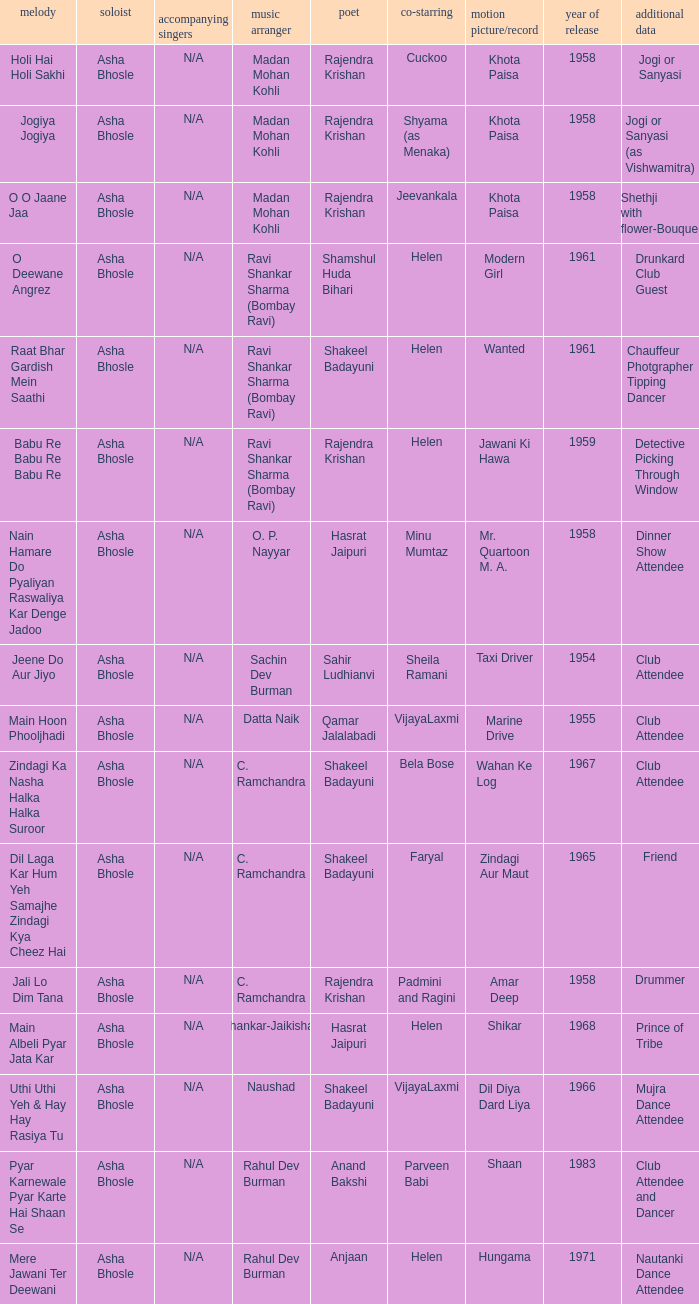How many co-singers were there when Parveen Babi co-starred? 1.0. 